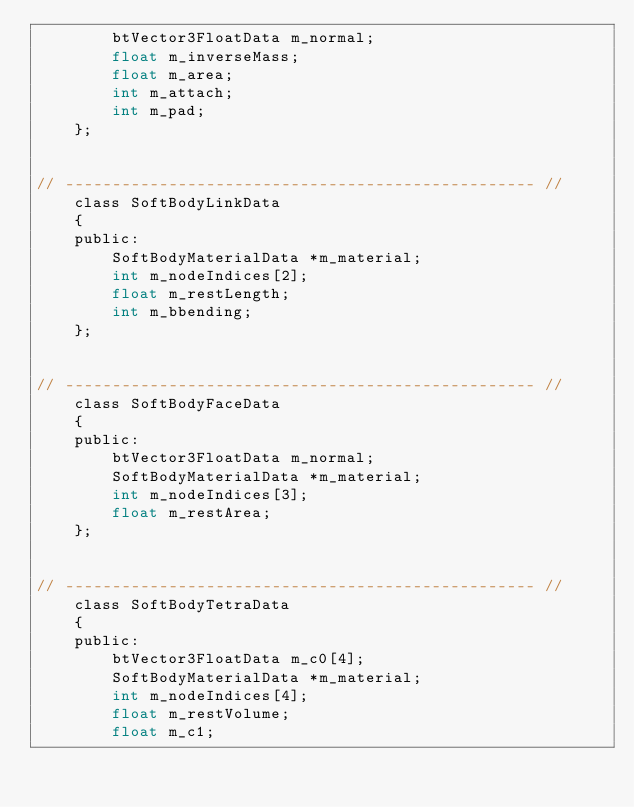Convert code to text. <code><loc_0><loc_0><loc_500><loc_500><_C_>        btVector3FloatData m_normal;
        float m_inverseMass;
        float m_area;
        int m_attach;
        int m_pad;
    };


// -------------------------------------------------- //
    class SoftBodyLinkData
    {
    public:
        SoftBodyMaterialData *m_material;
        int m_nodeIndices[2];
        float m_restLength;
        int m_bbending;
    };


// -------------------------------------------------- //
    class SoftBodyFaceData
    {
    public:
        btVector3FloatData m_normal;
        SoftBodyMaterialData *m_material;
        int m_nodeIndices[3];
        float m_restArea;
    };


// -------------------------------------------------- //
    class SoftBodyTetraData
    {
    public:
        btVector3FloatData m_c0[4];
        SoftBodyMaterialData *m_material;
        int m_nodeIndices[4];
        float m_restVolume;
        float m_c1;</code> 